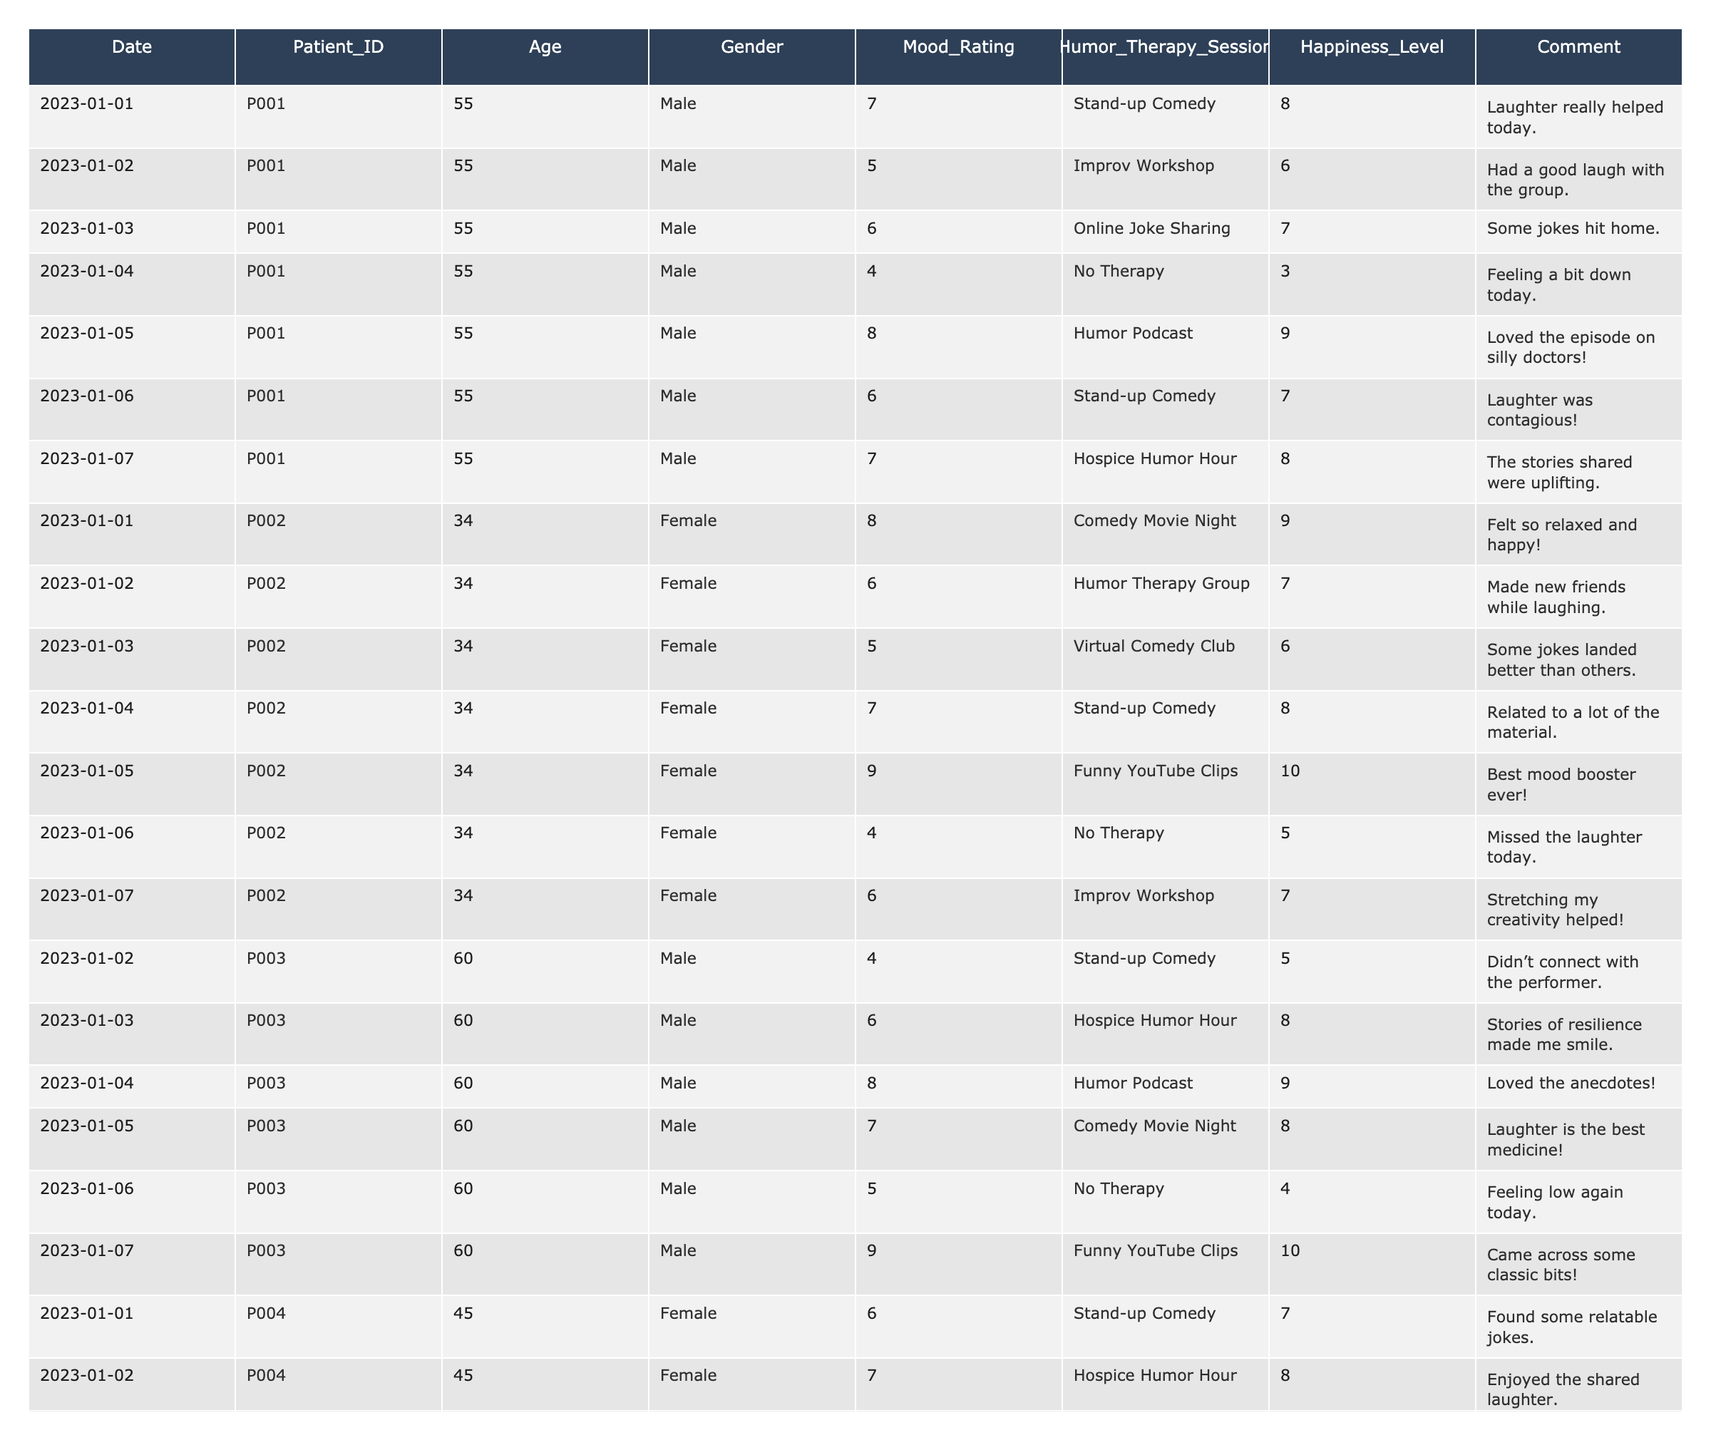What is the highest Mood Rating reported, and which patient reported it? By reviewing the Mood Ratings column, the highest value is 9, which was reported by both Patient P002 and Patient P004 on different days.
Answer: 9, P002 and P004 Which therapy session contributed to the lowest Mood Rating for Patient P001? Looking at Patient P001's entries, the lowest Mood Rating is 4 on 2023-01-04, where there was no therapy.
Answer: No Therapy What is the average Happiness Level of Patient P003? To find the average, we sum the Happiness Levels for Patient P003: (5 + 8 + 9 + 8 + 4 + 10) = 44, then divide by 6 entries: 44/6 = 7.33.
Answer: 7.33 Did Patient P002 improve in Mood Ratings after attending the Humor Therapy Group on January 2nd? Patient P002's Mood Rating decreased from 8 to 6 after attending the Humor Therapy Group but improved to 7 the following day and reached 9 thereafter. So, it seems she fluctuated but had a peak at 9.
Answer: Yes, fluctuated but peaked at 9 What was the Mood Rating on the day Patient P004 attended the Hospice Humor Hour? Patient P004 attended the Hospice Humor Hour on 2023-01-02, where the Mood Rating was 7.
Answer: 7 What therapy session had the highest Happiness Level for Patient P001? Analyzing Patient P001’s sessions, the highest Happiness Level of 9 was reported on the day he listened to the Humor Podcast.
Answer: Humor Podcast What is the difference in Mood Rating between the highest and lowest for Patient P002? Patient P002 had a highest Mood Rating of 9 and a lowest of 4: the difference is 9 - 4 = 5.
Answer: 5 How many Humor Therapy Sessions did Patient P003 attend with a Mood Rating of 6 or higher? Patient P003 had four sessions with Mood Ratings of 6 or higher: 6, 8, 8, and 9 from various therapy types.
Answer: 4 Which patient's Mood Ratings were always above 6? Reviewing Patient P002's entries, all Mood Ratings are above 6, indicating consistent positivity.
Answer: P002 What was the average Mood Rating for Patient P004 across all sessions? Adding Patient P004's Mood Ratings: (6 + 7 + 9 + 4 + 8 + 6) = 40, then divide by 6: 40/6 = 6.67.
Answer: 6.67 